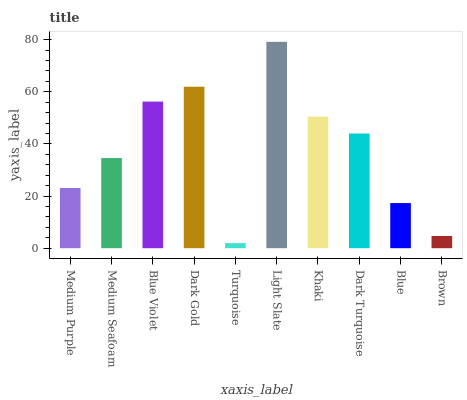Is Turquoise the minimum?
Answer yes or no. Yes. Is Light Slate the maximum?
Answer yes or no. Yes. Is Medium Seafoam the minimum?
Answer yes or no. No. Is Medium Seafoam the maximum?
Answer yes or no. No. Is Medium Seafoam greater than Medium Purple?
Answer yes or no. Yes. Is Medium Purple less than Medium Seafoam?
Answer yes or no. Yes. Is Medium Purple greater than Medium Seafoam?
Answer yes or no. No. Is Medium Seafoam less than Medium Purple?
Answer yes or no. No. Is Dark Turquoise the high median?
Answer yes or no. Yes. Is Medium Seafoam the low median?
Answer yes or no. Yes. Is Medium Purple the high median?
Answer yes or no. No. Is Light Slate the low median?
Answer yes or no. No. 